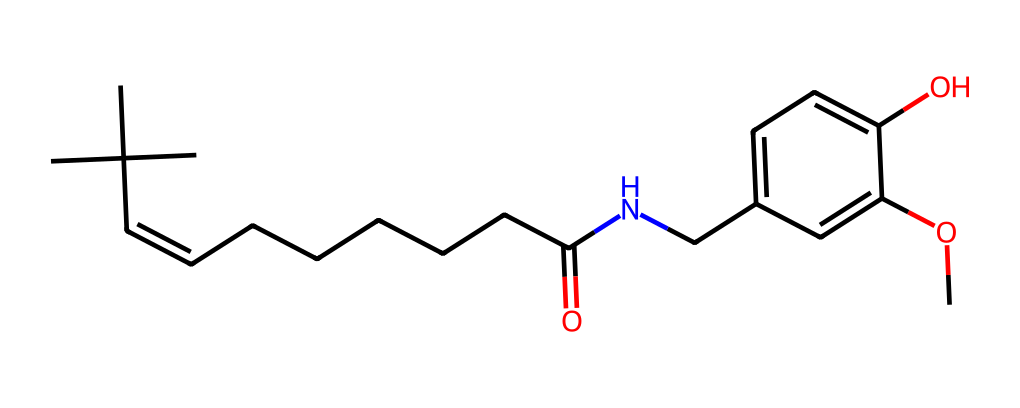How many carbon atoms are in this compound? By examining the SMILES representation, we can count the carbon (C) atoms. The structure shows multiple 'C' symbols, indicating carbon atoms in the backbone and branching. The total count from the structural representation amounts to 20 carbon atoms.
Answer: 20 What type of functional group is present in this molecule? Reviewing the SMILES, we identify -O- (methoxy) and -OH (hydroxyl) groups. The presence of these groups suggests that this compound contains both ether and alcohol functional groups, indicating that it’s likely to be a phenolic compound due to its aromatic ring and hydroxyl functionality.
Answer: phenolic What would be one geometric isomer of this compound? Geometric isomers arise due to restricted rotation around double bonds. In the provided SMILES, the (C=C) double bond allows for cis and trans isomers. The cis isomer would have the larger groups on the same side of the double bond, whereas the trans isomer would have them on opposite sides.
Answer: cis and trans isomers How does the presence of the hydroxyl group affect the compound's solubility? The hydroxyl (-OH) group is polar, which increases the compound's ability to interact with water molecules through hydrogen bonding. Thus, this function aids in improving solubility in polar solvents like water.
Answer: increases solubility What is the significance of the nitrogen atom in the structure? The nitrogen atom (part of the amine group) in this compound suggests that it can engage in hydrogen bonding and potentially behave as a weak base. Nitrogen's role is crucial in deriving physiological effects, especially related to how the body interacts with the spicy component present in capsaicin.
Answer: weak base What type of isomerism does this compound exhibit? Since this compound has a double bond (C=C) and can form different geometric arrangements due to restricted rotation, it exhibits geometric isomerism, specifically cis-trans (E/Z) isomerism. This configuration is vital in determining flavors and interactions in culinary applications.
Answer: geometric isomerism 